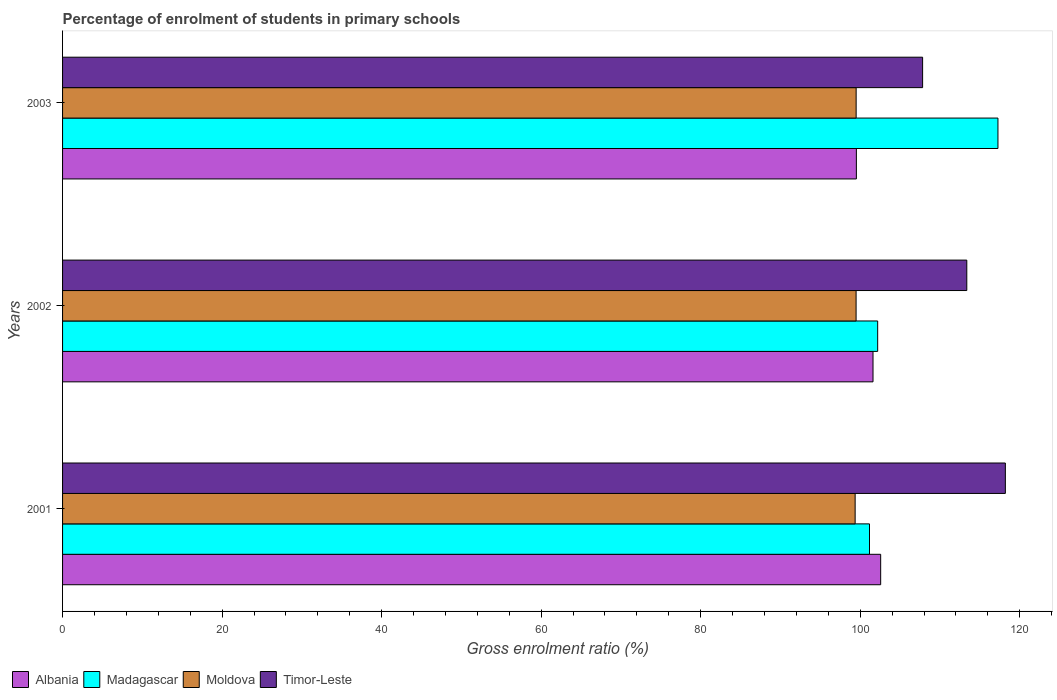What is the percentage of students enrolled in primary schools in Timor-Leste in 2002?
Provide a succinct answer. 113.36. Across all years, what is the maximum percentage of students enrolled in primary schools in Albania?
Keep it short and to the point. 102.56. Across all years, what is the minimum percentage of students enrolled in primary schools in Moldova?
Offer a terse response. 99.36. What is the total percentage of students enrolled in primary schools in Moldova in the graph?
Give a very brief answer. 298.33. What is the difference between the percentage of students enrolled in primary schools in Madagascar in 2002 and that in 2003?
Offer a very short reply. -15.08. What is the difference between the percentage of students enrolled in primary schools in Madagascar in 2001 and the percentage of students enrolled in primary schools in Albania in 2002?
Keep it short and to the point. -0.44. What is the average percentage of students enrolled in primary schools in Madagascar per year?
Your answer should be compact. 106.87. In the year 2002, what is the difference between the percentage of students enrolled in primary schools in Albania and percentage of students enrolled in primary schools in Madagascar?
Provide a short and direct response. -0.58. What is the ratio of the percentage of students enrolled in primary schools in Moldova in 2001 to that in 2002?
Your answer should be very brief. 1. Is the percentage of students enrolled in primary schools in Madagascar in 2001 less than that in 2002?
Provide a succinct answer. Yes. Is the difference between the percentage of students enrolled in primary schools in Albania in 2001 and 2002 greater than the difference between the percentage of students enrolled in primary schools in Madagascar in 2001 and 2002?
Provide a succinct answer. Yes. What is the difference between the highest and the second highest percentage of students enrolled in primary schools in Timor-Leste?
Ensure brevity in your answer.  4.83. What is the difference between the highest and the lowest percentage of students enrolled in primary schools in Madagascar?
Offer a very short reply. 16.1. In how many years, is the percentage of students enrolled in primary schools in Timor-Leste greater than the average percentage of students enrolled in primary schools in Timor-Leste taken over all years?
Your response must be concise. 2. Is it the case that in every year, the sum of the percentage of students enrolled in primary schools in Moldova and percentage of students enrolled in primary schools in Albania is greater than the sum of percentage of students enrolled in primary schools in Madagascar and percentage of students enrolled in primary schools in Timor-Leste?
Your answer should be very brief. No. What does the 1st bar from the top in 2001 represents?
Keep it short and to the point. Timor-Leste. What does the 2nd bar from the bottom in 2002 represents?
Ensure brevity in your answer.  Madagascar. Is it the case that in every year, the sum of the percentage of students enrolled in primary schools in Albania and percentage of students enrolled in primary schools in Timor-Leste is greater than the percentage of students enrolled in primary schools in Moldova?
Your answer should be very brief. Yes. How many bars are there?
Ensure brevity in your answer.  12. Are all the bars in the graph horizontal?
Keep it short and to the point. Yes. Does the graph contain any zero values?
Your answer should be compact. No. Does the graph contain grids?
Provide a succinct answer. No. How are the legend labels stacked?
Your response must be concise. Horizontal. What is the title of the graph?
Your answer should be compact. Percentage of enrolment of students in primary schools. What is the label or title of the X-axis?
Your response must be concise. Gross enrolment ratio (%). What is the label or title of the Y-axis?
Your answer should be compact. Years. What is the Gross enrolment ratio (%) in Albania in 2001?
Offer a very short reply. 102.56. What is the Gross enrolment ratio (%) of Madagascar in 2001?
Keep it short and to the point. 101.16. What is the Gross enrolment ratio (%) in Moldova in 2001?
Give a very brief answer. 99.36. What is the Gross enrolment ratio (%) in Timor-Leste in 2001?
Your answer should be very brief. 118.19. What is the Gross enrolment ratio (%) in Albania in 2002?
Offer a terse response. 101.6. What is the Gross enrolment ratio (%) in Madagascar in 2002?
Offer a terse response. 102.19. What is the Gross enrolment ratio (%) in Moldova in 2002?
Offer a terse response. 99.48. What is the Gross enrolment ratio (%) of Timor-Leste in 2002?
Make the answer very short. 113.36. What is the Gross enrolment ratio (%) of Albania in 2003?
Your answer should be compact. 99.52. What is the Gross enrolment ratio (%) in Madagascar in 2003?
Provide a short and direct response. 117.26. What is the Gross enrolment ratio (%) of Moldova in 2003?
Keep it short and to the point. 99.49. What is the Gross enrolment ratio (%) of Timor-Leste in 2003?
Your answer should be compact. 107.82. Across all years, what is the maximum Gross enrolment ratio (%) of Albania?
Offer a very short reply. 102.56. Across all years, what is the maximum Gross enrolment ratio (%) of Madagascar?
Your response must be concise. 117.26. Across all years, what is the maximum Gross enrolment ratio (%) in Moldova?
Offer a terse response. 99.49. Across all years, what is the maximum Gross enrolment ratio (%) of Timor-Leste?
Your response must be concise. 118.19. Across all years, what is the minimum Gross enrolment ratio (%) in Albania?
Offer a terse response. 99.52. Across all years, what is the minimum Gross enrolment ratio (%) of Madagascar?
Offer a terse response. 101.16. Across all years, what is the minimum Gross enrolment ratio (%) in Moldova?
Offer a terse response. 99.36. Across all years, what is the minimum Gross enrolment ratio (%) in Timor-Leste?
Ensure brevity in your answer.  107.82. What is the total Gross enrolment ratio (%) in Albania in the graph?
Keep it short and to the point. 303.68. What is the total Gross enrolment ratio (%) of Madagascar in the graph?
Provide a short and direct response. 320.61. What is the total Gross enrolment ratio (%) of Moldova in the graph?
Give a very brief answer. 298.33. What is the total Gross enrolment ratio (%) in Timor-Leste in the graph?
Make the answer very short. 339.37. What is the difference between the Gross enrolment ratio (%) of Albania in 2001 and that in 2002?
Ensure brevity in your answer.  0.96. What is the difference between the Gross enrolment ratio (%) of Madagascar in 2001 and that in 2002?
Your answer should be very brief. -1.02. What is the difference between the Gross enrolment ratio (%) of Moldova in 2001 and that in 2002?
Offer a very short reply. -0.12. What is the difference between the Gross enrolment ratio (%) of Timor-Leste in 2001 and that in 2002?
Ensure brevity in your answer.  4.83. What is the difference between the Gross enrolment ratio (%) in Albania in 2001 and that in 2003?
Your answer should be very brief. 3.05. What is the difference between the Gross enrolment ratio (%) of Madagascar in 2001 and that in 2003?
Provide a short and direct response. -16.1. What is the difference between the Gross enrolment ratio (%) of Moldova in 2001 and that in 2003?
Provide a short and direct response. -0.13. What is the difference between the Gross enrolment ratio (%) in Timor-Leste in 2001 and that in 2003?
Your answer should be very brief. 10.37. What is the difference between the Gross enrolment ratio (%) of Albania in 2002 and that in 2003?
Your response must be concise. 2.09. What is the difference between the Gross enrolment ratio (%) in Madagascar in 2002 and that in 2003?
Your answer should be compact. -15.08. What is the difference between the Gross enrolment ratio (%) in Moldova in 2002 and that in 2003?
Provide a short and direct response. -0.01. What is the difference between the Gross enrolment ratio (%) of Timor-Leste in 2002 and that in 2003?
Your response must be concise. 5.54. What is the difference between the Gross enrolment ratio (%) in Albania in 2001 and the Gross enrolment ratio (%) in Madagascar in 2002?
Offer a very short reply. 0.38. What is the difference between the Gross enrolment ratio (%) of Albania in 2001 and the Gross enrolment ratio (%) of Moldova in 2002?
Offer a very short reply. 3.08. What is the difference between the Gross enrolment ratio (%) in Albania in 2001 and the Gross enrolment ratio (%) in Timor-Leste in 2002?
Make the answer very short. -10.8. What is the difference between the Gross enrolment ratio (%) of Madagascar in 2001 and the Gross enrolment ratio (%) of Moldova in 2002?
Offer a terse response. 1.68. What is the difference between the Gross enrolment ratio (%) in Madagascar in 2001 and the Gross enrolment ratio (%) in Timor-Leste in 2002?
Offer a very short reply. -12.2. What is the difference between the Gross enrolment ratio (%) of Moldova in 2001 and the Gross enrolment ratio (%) of Timor-Leste in 2002?
Offer a very short reply. -14. What is the difference between the Gross enrolment ratio (%) of Albania in 2001 and the Gross enrolment ratio (%) of Madagascar in 2003?
Your answer should be compact. -14.7. What is the difference between the Gross enrolment ratio (%) in Albania in 2001 and the Gross enrolment ratio (%) in Moldova in 2003?
Your answer should be compact. 3.08. What is the difference between the Gross enrolment ratio (%) in Albania in 2001 and the Gross enrolment ratio (%) in Timor-Leste in 2003?
Give a very brief answer. -5.26. What is the difference between the Gross enrolment ratio (%) of Madagascar in 2001 and the Gross enrolment ratio (%) of Moldova in 2003?
Ensure brevity in your answer.  1.67. What is the difference between the Gross enrolment ratio (%) of Madagascar in 2001 and the Gross enrolment ratio (%) of Timor-Leste in 2003?
Your response must be concise. -6.66. What is the difference between the Gross enrolment ratio (%) of Moldova in 2001 and the Gross enrolment ratio (%) of Timor-Leste in 2003?
Keep it short and to the point. -8.46. What is the difference between the Gross enrolment ratio (%) in Albania in 2002 and the Gross enrolment ratio (%) in Madagascar in 2003?
Provide a short and direct response. -15.66. What is the difference between the Gross enrolment ratio (%) of Albania in 2002 and the Gross enrolment ratio (%) of Moldova in 2003?
Offer a very short reply. 2.11. What is the difference between the Gross enrolment ratio (%) of Albania in 2002 and the Gross enrolment ratio (%) of Timor-Leste in 2003?
Give a very brief answer. -6.22. What is the difference between the Gross enrolment ratio (%) of Madagascar in 2002 and the Gross enrolment ratio (%) of Moldova in 2003?
Provide a succinct answer. 2.7. What is the difference between the Gross enrolment ratio (%) in Madagascar in 2002 and the Gross enrolment ratio (%) in Timor-Leste in 2003?
Provide a short and direct response. -5.63. What is the difference between the Gross enrolment ratio (%) in Moldova in 2002 and the Gross enrolment ratio (%) in Timor-Leste in 2003?
Offer a very short reply. -8.34. What is the average Gross enrolment ratio (%) of Albania per year?
Provide a short and direct response. 101.23. What is the average Gross enrolment ratio (%) of Madagascar per year?
Make the answer very short. 106.87. What is the average Gross enrolment ratio (%) of Moldova per year?
Provide a succinct answer. 99.44. What is the average Gross enrolment ratio (%) in Timor-Leste per year?
Your answer should be compact. 113.12. In the year 2001, what is the difference between the Gross enrolment ratio (%) in Albania and Gross enrolment ratio (%) in Madagascar?
Ensure brevity in your answer.  1.4. In the year 2001, what is the difference between the Gross enrolment ratio (%) in Albania and Gross enrolment ratio (%) in Moldova?
Give a very brief answer. 3.2. In the year 2001, what is the difference between the Gross enrolment ratio (%) of Albania and Gross enrolment ratio (%) of Timor-Leste?
Your answer should be very brief. -15.63. In the year 2001, what is the difference between the Gross enrolment ratio (%) in Madagascar and Gross enrolment ratio (%) in Moldova?
Your answer should be compact. 1.8. In the year 2001, what is the difference between the Gross enrolment ratio (%) in Madagascar and Gross enrolment ratio (%) in Timor-Leste?
Offer a terse response. -17.03. In the year 2001, what is the difference between the Gross enrolment ratio (%) in Moldova and Gross enrolment ratio (%) in Timor-Leste?
Your response must be concise. -18.83. In the year 2002, what is the difference between the Gross enrolment ratio (%) of Albania and Gross enrolment ratio (%) of Madagascar?
Provide a succinct answer. -0.58. In the year 2002, what is the difference between the Gross enrolment ratio (%) in Albania and Gross enrolment ratio (%) in Moldova?
Your response must be concise. 2.12. In the year 2002, what is the difference between the Gross enrolment ratio (%) in Albania and Gross enrolment ratio (%) in Timor-Leste?
Offer a very short reply. -11.76. In the year 2002, what is the difference between the Gross enrolment ratio (%) of Madagascar and Gross enrolment ratio (%) of Moldova?
Ensure brevity in your answer.  2.71. In the year 2002, what is the difference between the Gross enrolment ratio (%) in Madagascar and Gross enrolment ratio (%) in Timor-Leste?
Provide a short and direct response. -11.17. In the year 2002, what is the difference between the Gross enrolment ratio (%) of Moldova and Gross enrolment ratio (%) of Timor-Leste?
Provide a short and direct response. -13.88. In the year 2003, what is the difference between the Gross enrolment ratio (%) in Albania and Gross enrolment ratio (%) in Madagascar?
Your response must be concise. -17.75. In the year 2003, what is the difference between the Gross enrolment ratio (%) in Albania and Gross enrolment ratio (%) in Moldova?
Provide a short and direct response. 0.03. In the year 2003, what is the difference between the Gross enrolment ratio (%) of Albania and Gross enrolment ratio (%) of Timor-Leste?
Make the answer very short. -8.3. In the year 2003, what is the difference between the Gross enrolment ratio (%) in Madagascar and Gross enrolment ratio (%) in Moldova?
Give a very brief answer. 17.78. In the year 2003, what is the difference between the Gross enrolment ratio (%) in Madagascar and Gross enrolment ratio (%) in Timor-Leste?
Your answer should be very brief. 9.45. In the year 2003, what is the difference between the Gross enrolment ratio (%) of Moldova and Gross enrolment ratio (%) of Timor-Leste?
Your response must be concise. -8.33. What is the ratio of the Gross enrolment ratio (%) in Albania in 2001 to that in 2002?
Provide a short and direct response. 1.01. What is the ratio of the Gross enrolment ratio (%) of Madagascar in 2001 to that in 2002?
Keep it short and to the point. 0.99. What is the ratio of the Gross enrolment ratio (%) in Timor-Leste in 2001 to that in 2002?
Keep it short and to the point. 1.04. What is the ratio of the Gross enrolment ratio (%) in Albania in 2001 to that in 2003?
Make the answer very short. 1.03. What is the ratio of the Gross enrolment ratio (%) in Madagascar in 2001 to that in 2003?
Provide a short and direct response. 0.86. What is the ratio of the Gross enrolment ratio (%) in Timor-Leste in 2001 to that in 2003?
Give a very brief answer. 1.1. What is the ratio of the Gross enrolment ratio (%) in Albania in 2002 to that in 2003?
Your response must be concise. 1.02. What is the ratio of the Gross enrolment ratio (%) of Madagascar in 2002 to that in 2003?
Provide a succinct answer. 0.87. What is the ratio of the Gross enrolment ratio (%) of Moldova in 2002 to that in 2003?
Ensure brevity in your answer.  1. What is the ratio of the Gross enrolment ratio (%) of Timor-Leste in 2002 to that in 2003?
Offer a very short reply. 1.05. What is the difference between the highest and the second highest Gross enrolment ratio (%) of Albania?
Ensure brevity in your answer.  0.96. What is the difference between the highest and the second highest Gross enrolment ratio (%) of Madagascar?
Offer a very short reply. 15.08. What is the difference between the highest and the second highest Gross enrolment ratio (%) in Moldova?
Your answer should be very brief. 0.01. What is the difference between the highest and the second highest Gross enrolment ratio (%) of Timor-Leste?
Provide a succinct answer. 4.83. What is the difference between the highest and the lowest Gross enrolment ratio (%) in Albania?
Offer a terse response. 3.05. What is the difference between the highest and the lowest Gross enrolment ratio (%) in Madagascar?
Ensure brevity in your answer.  16.1. What is the difference between the highest and the lowest Gross enrolment ratio (%) of Moldova?
Provide a short and direct response. 0.13. What is the difference between the highest and the lowest Gross enrolment ratio (%) of Timor-Leste?
Offer a terse response. 10.37. 